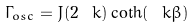<formula> <loc_0><loc_0><loc_500><loc_500>\Gamma _ { o s c } = J ( 2 \ k ) \coth ( \ k \beta )</formula> 